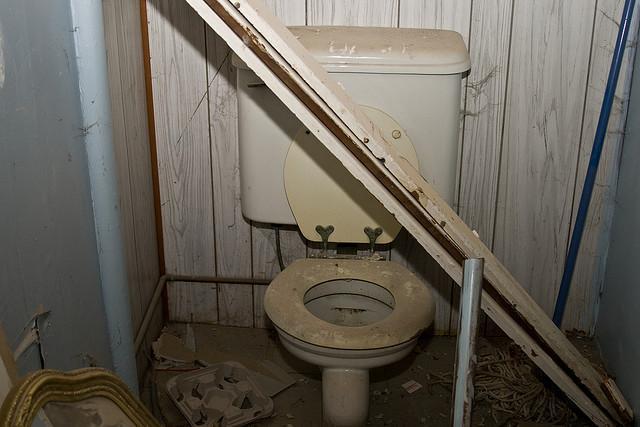How many pair of scissors are in the picture?
Give a very brief answer. 0. 